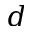Convert formula to latex. <formula><loc_0><loc_0><loc_500><loc_500>d</formula> 